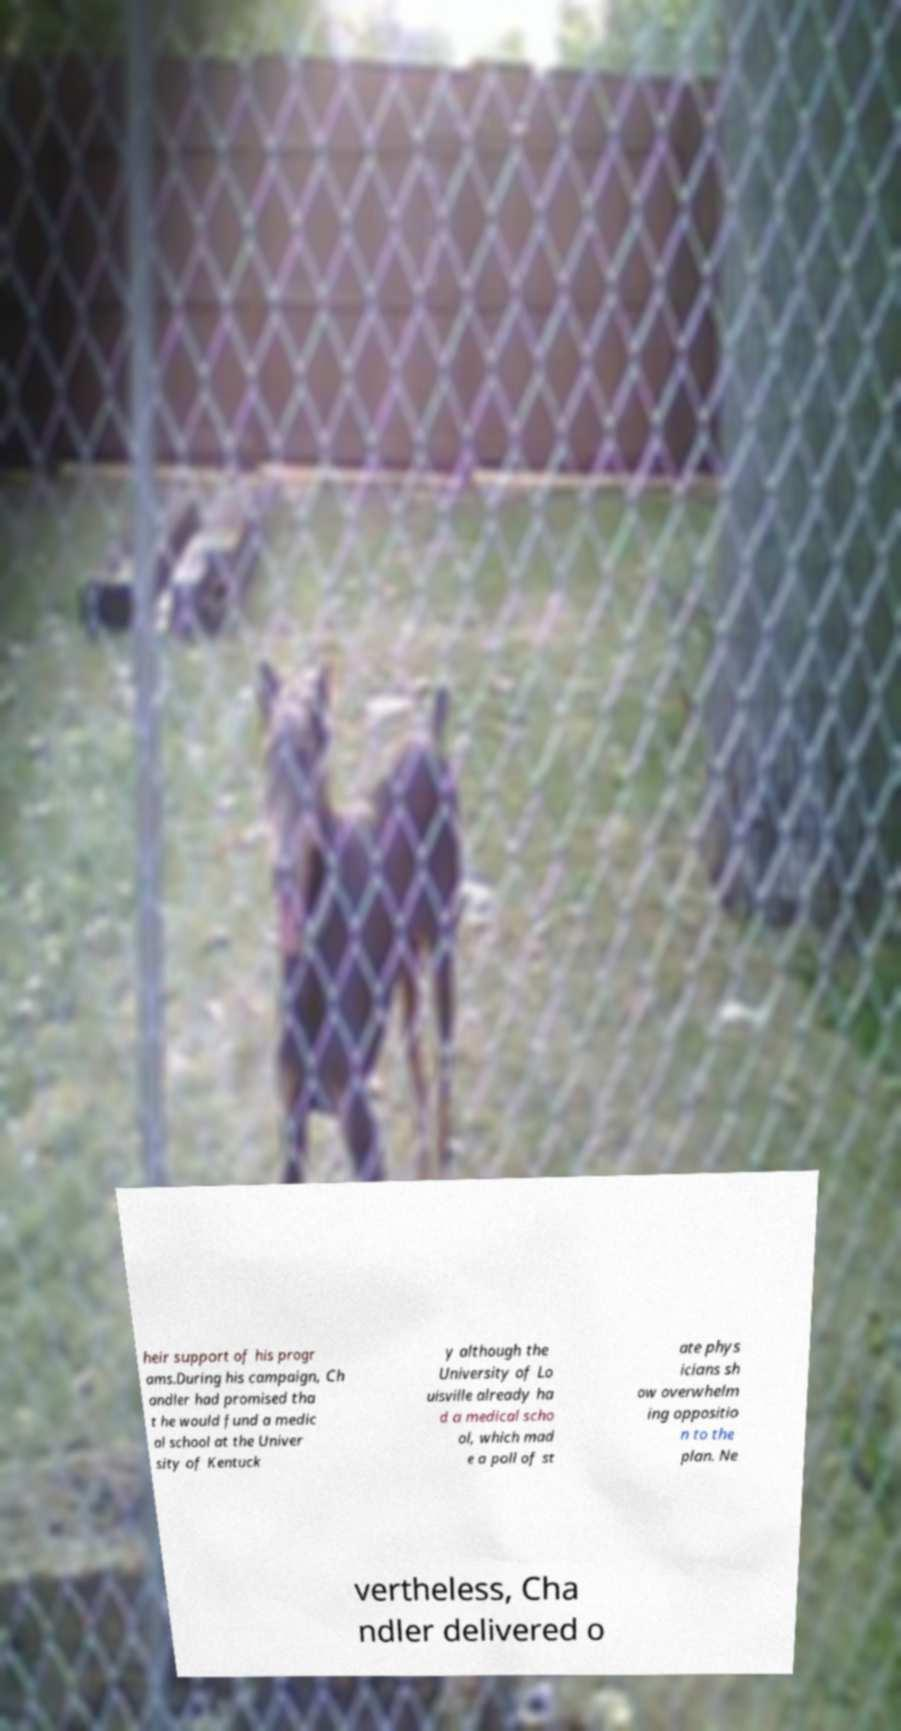What messages or text are displayed in this image? I need them in a readable, typed format. heir support of his progr ams.During his campaign, Ch andler had promised tha t he would fund a medic al school at the Univer sity of Kentuck y although the University of Lo uisville already ha d a medical scho ol, which mad e a poll of st ate phys icians sh ow overwhelm ing oppositio n to the plan. Ne vertheless, Cha ndler delivered o 